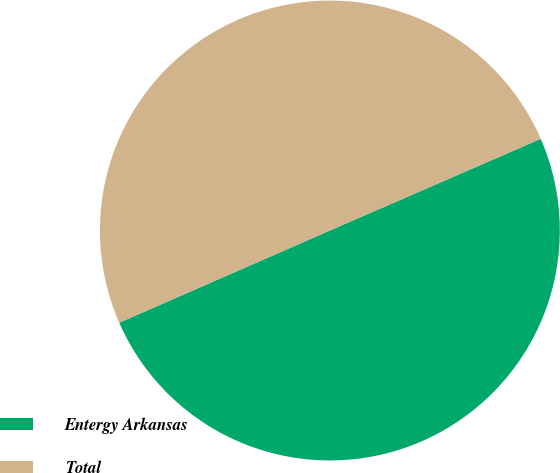<chart> <loc_0><loc_0><loc_500><loc_500><pie_chart><fcel>Entergy Arkansas<fcel>Total<nl><fcel>49.96%<fcel>50.04%<nl></chart> 